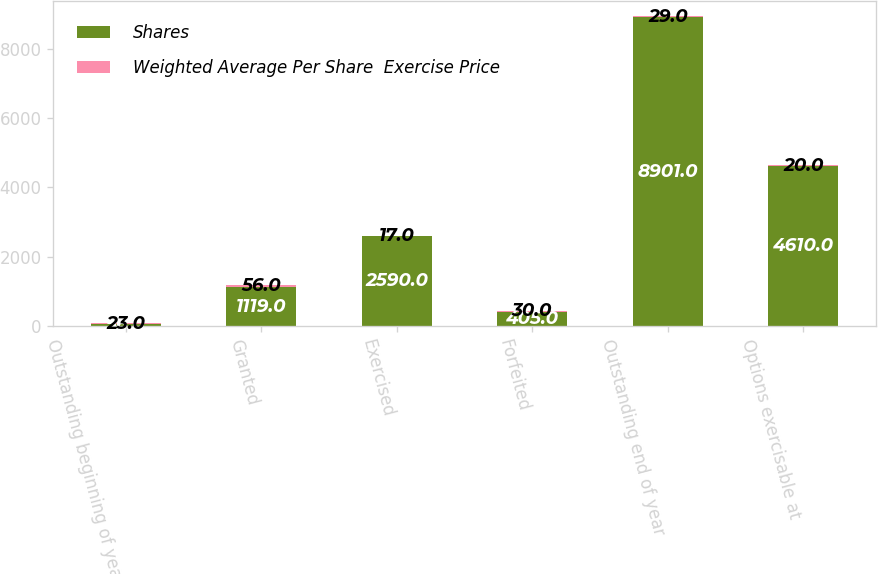Convert chart. <chart><loc_0><loc_0><loc_500><loc_500><stacked_bar_chart><ecel><fcel>Outstanding beginning of year<fcel>Granted<fcel>Exercised<fcel>Forfeited<fcel>Outstanding end of year<fcel>Options exercisable at<nl><fcel>Shares<fcel>56<fcel>1119<fcel>2590<fcel>405<fcel>8901<fcel>4610<nl><fcel>Weighted Average Per Share  Exercise Price<fcel>23<fcel>56<fcel>17<fcel>30<fcel>29<fcel>20<nl></chart> 